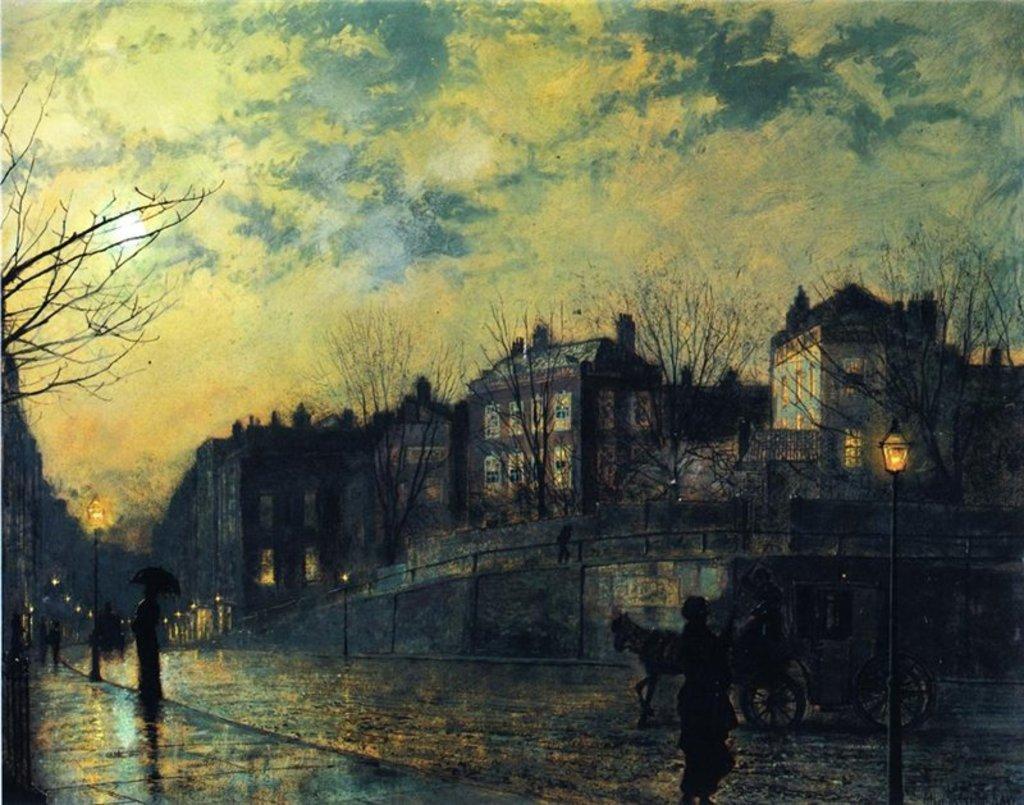Describe this image in one or two sentences. In this picture, we can see an art of a building, a few people, cart with an animal, poles with lights, dry trees, and we can see the sky with clouds. 